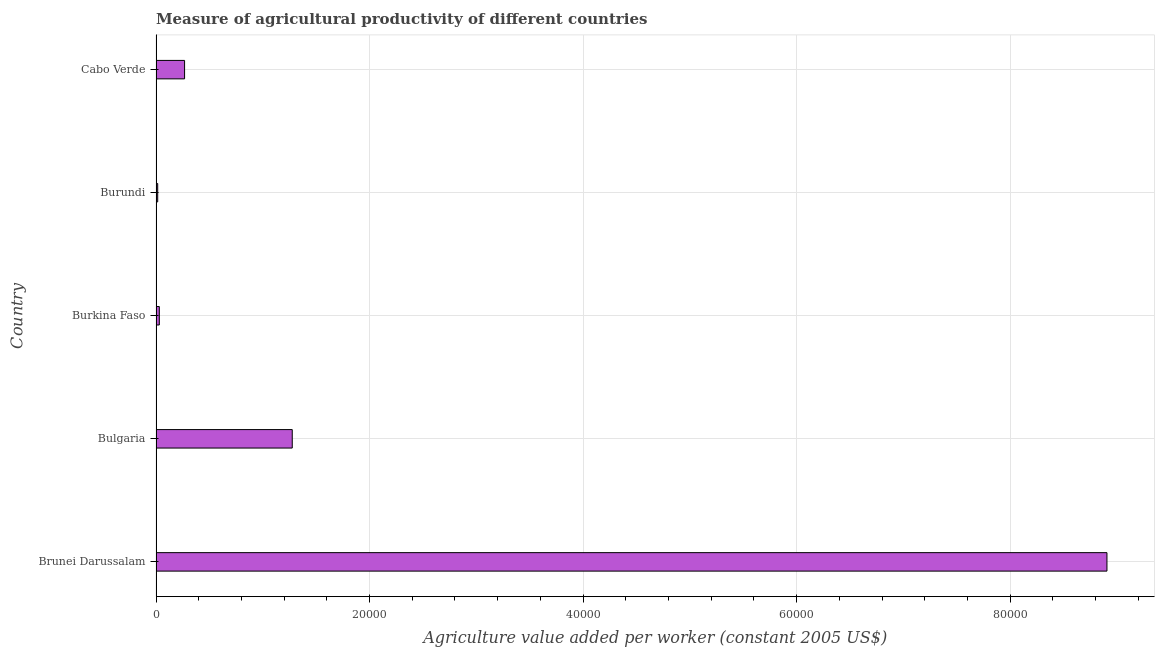What is the title of the graph?
Your response must be concise. Measure of agricultural productivity of different countries. What is the label or title of the X-axis?
Keep it short and to the point. Agriculture value added per worker (constant 2005 US$). What is the agriculture value added per worker in Cabo Verde?
Ensure brevity in your answer.  2674.6. Across all countries, what is the maximum agriculture value added per worker?
Your answer should be compact. 8.91e+04. Across all countries, what is the minimum agriculture value added per worker?
Keep it short and to the point. 156.89. In which country was the agriculture value added per worker maximum?
Your response must be concise. Brunei Darussalam. In which country was the agriculture value added per worker minimum?
Keep it short and to the point. Burundi. What is the sum of the agriculture value added per worker?
Your answer should be compact. 1.05e+05. What is the difference between the agriculture value added per worker in Burkina Faso and Cabo Verde?
Make the answer very short. -2366.92. What is the average agriculture value added per worker per country?
Offer a very short reply. 2.10e+04. What is the median agriculture value added per worker?
Give a very brief answer. 2674.6. What is the ratio of the agriculture value added per worker in Burkina Faso to that in Cabo Verde?
Make the answer very short. 0.12. What is the difference between the highest and the second highest agriculture value added per worker?
Your answer should be very brief. 7.63e+04. What is the difference between the highest and the lowest agriculture value added per worker?
Give a very brief answer. 8.89e+04. In how many countries, is the agriculture value added per worker greater than the average agriculture value added per worker taken over all countries?
Ensure brevity in your answer.  1. Are all the bars in the graph horizontal?
Give a very brief answer. Yes. What is the difference between two consecutive major ticks on the X-axis?
Offer a very short reply. 2.00e+04. What is the Agriculture value added per worker (constant 2005 US$) of Brunei Darussalam?
Your answer should be compact. 8.91e+04. What is the Agriculture value added per worker (constant 2005 US$) of Bulgaria?
Your answer should be very brief. 1.28e+04. What is the Agriculture value added per worker (constant 2005 US$) of Burkina Faso?
Give a very brief answer. 307.67. What is the Agriculture value added per worker (constant 2005 US$) in Burundi?
Provide a short and direct response. 156.89. What is the Agriculture value added per worker (constant 2005 US$) of Cabo Verde?
Your answer should be very brief. 2674.6. What is the difference between the Agriculture value added per worker (constant 2005 US$) in Brunei Darussalam and Bulgaria?
Your answer should be very brief. 7.63e+04. What is the difference between the Agriculture value added per worker (constant 2005 US$) in Brunei Darussalam and Burkina Faso?
Keep it short and to the point. 8.88e+04. What is the difference between the Agriculture value added per worker (constant 2005 US$) in Brunei Darussalam and Burundi?
Provide a succinct answer. 8.89e+04. What is the difference between the Agriculture value added per worker (constant 2005 US$) in Brunei Darussalam and Cabo Verde?
Your answer should be very brief. 8.64e+04. What is the difference between the Agriculture value added per worker (constant 2005 US$) in Bulgaria and Burkina Faso?
Give a very brief answer. 1.25e+04. What is the difference between the Agriculture value added per worker (constant 2005 US$) in Bulgaria and Burundi?
Your answer should be compact. 1.26e+04. What is the difference between the Agriculture value added per worker (constant 2005 US$) in Bulgaria and Cabo Verde?
Offer a very short reply. 1.01e+04. What is the difference between the Agriculture value added per worker (constant 2005 US$) in Burkina Faso and Burundi?
Your answer should be compact. 150.78. What is the difference between the Agriculture value added per worker (constant 2005 US$) in Burkina Faso and Cabo Verde?
Keep it short and to the point. -2366.92. What is the difference between the Agriculture value added per worker (constant 2005 US$) in Burundi and Cabo Verde?
Provide a succinct answer. -2517.7. What is the ratio of the Agriculture value added per worker (constant 2005 US$) in Brunei Darussalam to that in Bulgaria?
Ensure brevity in your answer.  6.98. What is the ratio of the Agriculture value added per worker (constant 2005 US$) in Brunei Darussalam to that in Burkina Faso?
Provide a short and direct response. 289.46. What is the ratio of the Agriculture value added per worker (constant 2005 US$) in Brunei Darussalam to that in Burundi?
Offer a very short reply. 567.64. What is the ratio of the Agriculture value added per worker (constant 2005 US$) in Brunei Darussalam to that in Cabo Verde?
Offer a terse response. 33.3. What is the ratio of the Agriculture value added per worker (constant 2005 US$) in Bulgaria to that in Burkina Faso?
Make the answer very short. 41.47. What is the ratio of the Agriculture value added per worker (constant 2005 US$) in Bulgaria to that in Burundi?
Offer a very short reply. 81.32. What is the ratio of the Agriculture value added per worker (constant 2005 US$) in Bulgaria to that in Cabo Verde?
Provide a succinct answer. 4.77. What is the ratio of the Agriculture value added per worker (constant 2005 US$) in Burkina Faso to that in Burundi?
Your answer should be compact. 1.96. What is the ratio of the Agriculture value added per worker (constant 2005 US$) in Burkina Faso to that in Cabo Verde?
Offer a very short reply. 0.12. What is the ratio of the Agriculture value added per worker (constant 2005 US$) in Burundi to that in Cabo Verde?
Ensure brevity in your answer.  0.06. 